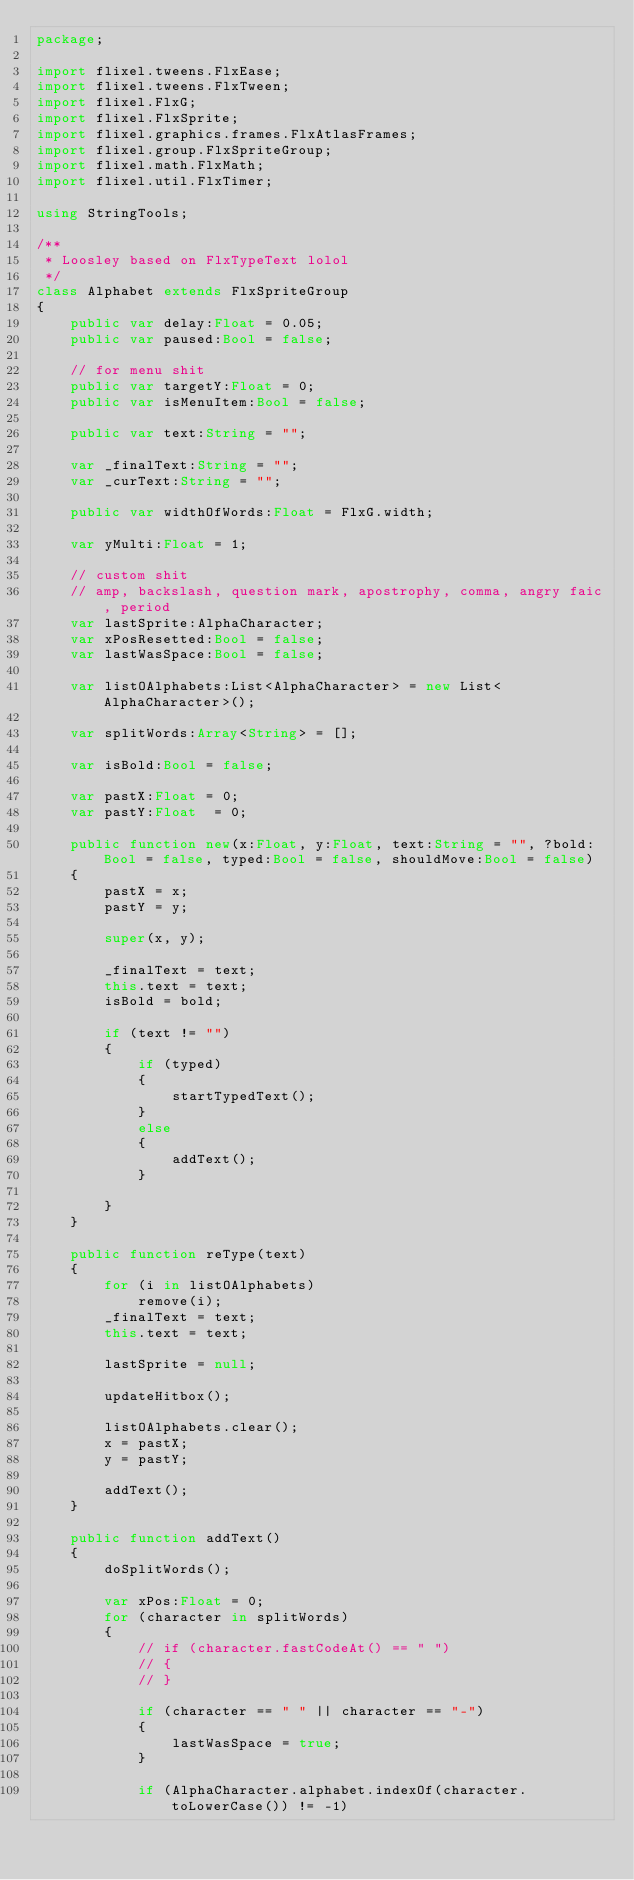<code> <loc_0><loc_0><loc_500><loc_500><_Haxe_>package;

import flixel.tweens.FlxEase;
import flixel.tweens.FlxTween;
import flixel.FlxG;
import flixel.FlxSprite;
import flixel.graphics.frames.FlxAtlasFrames;
import flixel.group.FlxSpriteGroup;
import flixel.math.FlxMath;
import flixel.util.FlxTimer;

using StringTools;

/**
 * Loosley based on FlxTypeText lolol
 */
class Alphabet extends FlxSpriteGroup
{
	public var delay:Float = 0.05;
	public var paused:Bool = false;

	// for menu shit
	public var targetY:Float = 0;
	public var isMenuItem:Bool = false;

	public var text:String = "";

	var _finalText:String = "";
	var _curText:String = "";

	public var widthOfWords:Float = FlxG.width;

	var yMulti:Float = 1;

	// custom shit
	// amp, backslash, question mark, apostrophy, comma, angry faic, period
	var lastSprite:AlphaCharacter;
	var xPosResetted:Bool = false;
	var lastWasSpace:Bool = false;

	var listOAlphabets:List<AlphaCharacter> = new List<AlphaCharacter>();

	var splitWords:Array<String> = [];

	var isBold:Bool = false;

	var pastX:Float = 0;
	var pastY:Float  = 0;

	public function new(x:Float, y:Float, text:String = "", ?bold:Bool = false, typed:Bool = false, shouldMove:Bool = false)
	{
		pastX = x;
		pastY = y;

		super(x, y);

		_finalText = text;
		this.text = text;
		isBold = bold;

		if (text != "")
		{
			if (typed)
			{
				startTypedText();
			}
			else
			{
				addText();
			}

		}
	}

	public function reType(text)
	{
		for (i in listOAlphabets)
			remove(i);
		_finalText = text;
		this.text = text;

		lastSprite = null;

		updateHitbox();

		listOAlphabets.clear();
		x = pastX;
		y = pastY;
		
		addText();
	}

	public function addText()
	{
		doSplitWords();

		var xPos:Float = 0;
		for (character in splitWords)
		{
			// if (character.fastCodeAt() == " ")
			// {
			// }

			if (character == " " || character == "-")
			{
				lastWasSpace = true;
			}

			if (AlphaCharacter.alphabet.indexOf(character.toLowerCase()) != -1)</code> 